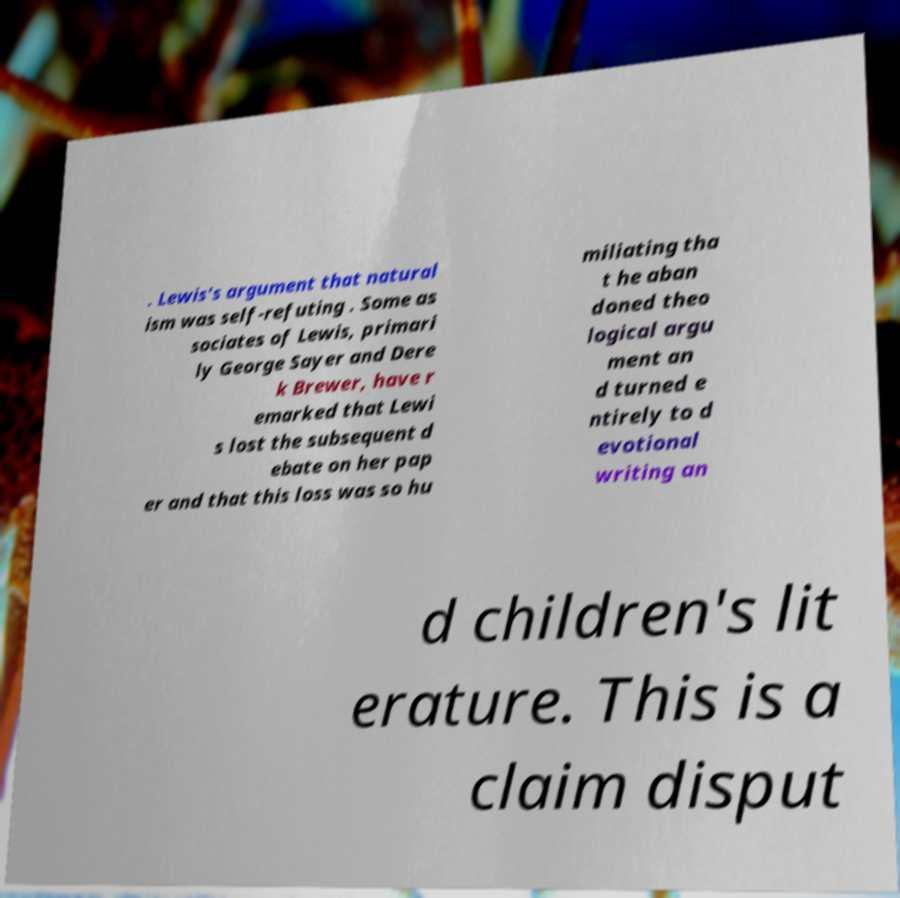I need the written content from this picture converted into text. Can you do that? . Lewis's argument that natural ism was self-refuting . Some as sociates of Lewis, primari ly George Sayer and Dere k Brewer, have r emarked that Lewi s lost the subsequent d ebate on her pap er and that this loss was so hu miliating tha t he aban doned theo logical argu ment an d turned e ntirely to d evotional writing an d children's lit erature. This is a claim disput 